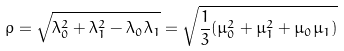Convert formula to latex. <formula><loc_0><loc_0><loc_500><loc_500>\rho = \sqrt { \lambda _ { 0 } ^ { 2 } + \lambda _ { 1 } ^ { 2 } - \lambda _ { 0 } \lambda _ { 1 } } = \sqrt { \frac { 1 } { 3 } ( \mu _ { 0 } ^ { 2 } + \mu _ { 1 } ^ { 2 } + \mu _ { 0 } \mu _ { 1 } ) }</formula> 